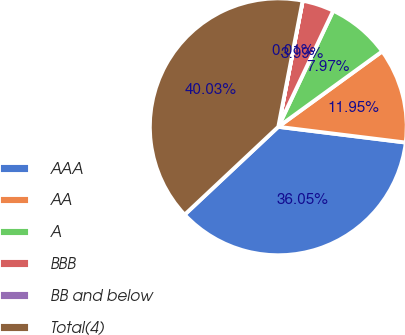<chart> <loc_0><loc_0><loc_500><loc_500><pie_chart><fcel>AAA<fcel>AA<fcel>A<fcel>BBB<fcel>BB and below<fcel>Total(4)<nl><fcel>36.05%<fcel>11.95%<fcel>7.97%<fcel>3.99%<fcel>0.01%<fcel>40.03%<nl></chart> 